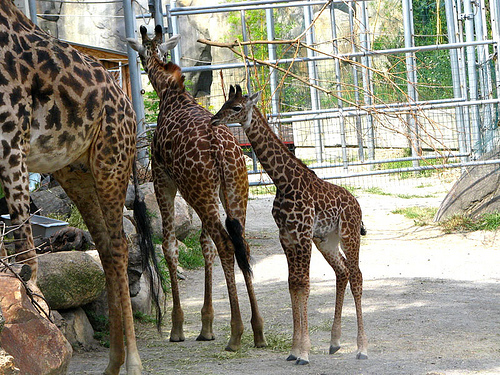Based on their postures, what might the giraffes be doing right now? The giraffe on the left, with its neck extended upwards towards the enclosure's apparatus, may be investigating or trying to reach something above. The one on the right, whose head is turned away, might be observing its surroundings or could have been momentarily distracted by something outside the camera's view. 